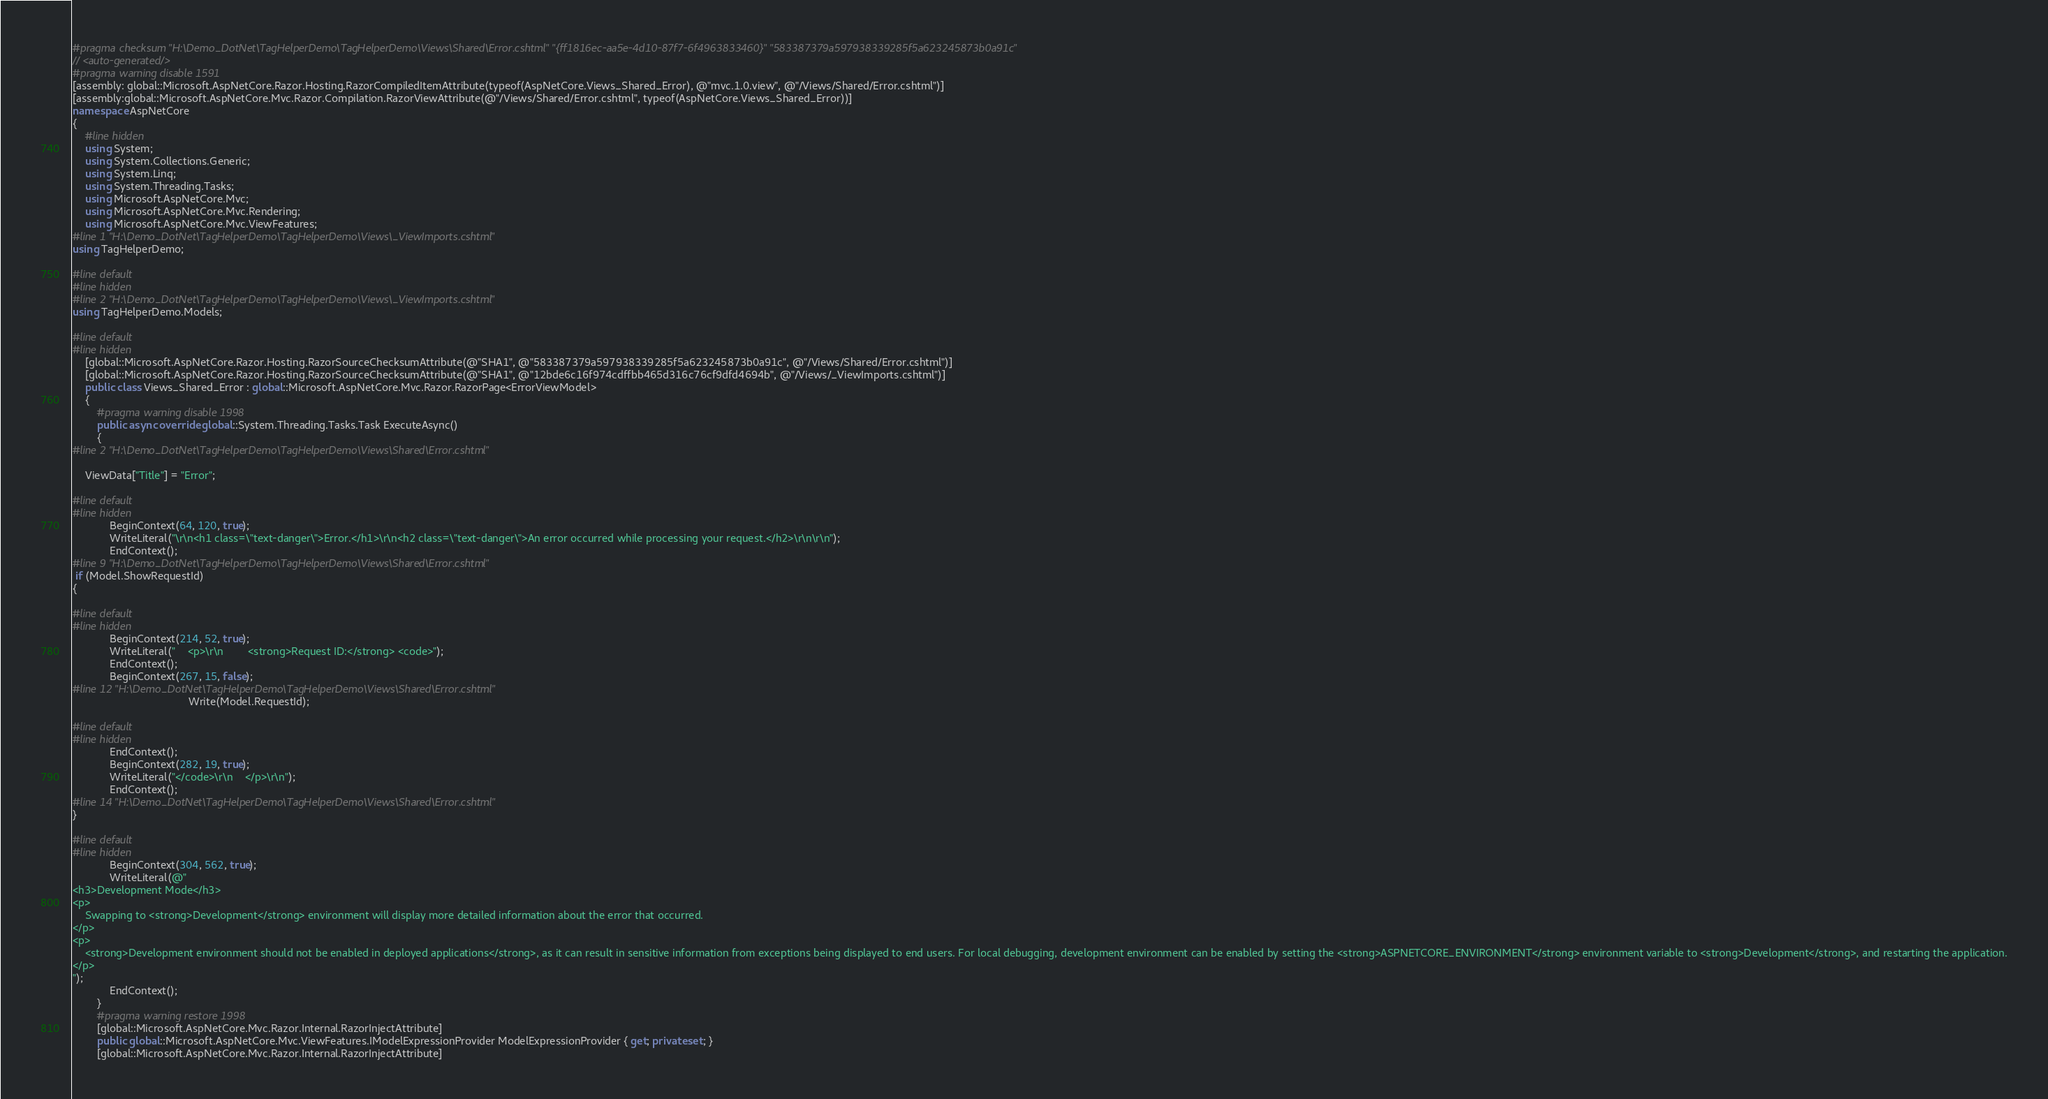Convert code to text. <code><loc_0><loc_0><loc_500><loc_500><_C#_>#pragma checksum "H:\Demo_DotNet\TagHelperDemo\TagHelperDemo\Views\Shared\Error.cshtml" "{ff1816ec-aa5e-4d10-87f7-6f4963833460}" "583387379a597938339285f5a623245873b0a91c"
// <auto-generated/>
#pragma warning disable 1591
[assembly: global::Microsoft.AspNetCore.Razor.Hosting.RazorCompiledItemAttribute(typeof(AspNetCore.Views_Shared_Error), @"mvc.1.0.view", @"/Views/Shared/Error.cshtml")]
[assembly:global::Microsoft.AspNetCore.Mvc.Razor.Compilation.RazorViewAttribute(@"/Views/Shared/Error.cshtml", typeof(AspNetCore.Views_Shared_Error))]
namespace AspNetCore
{
    #line hidden
    using System;
    using System.Collections.Generic;
    using System.Linq;
    using System.Threading.Tasks;
    using Microsoft.AspNetCore.Mvc;
    using Microsoft.AspNetCore.Mvc.Rendering;
    using Microsoft.AspNetCore.Mvc.ViewFeatures;
#line 1 "H:\Demo_DotNet\TagHelperDemo\TagHelperDemo\Views\_ViewImports.cshtml"
using TagHelperDemo;

#line default
#line hidden
#line 2 "H:\Demo_DotNet\TagHelperDemo\TagHelperDemo\Views\_ViewImports.cshtml"
using TagHelperDemo.Models;

#line default
#line hidden
    [global::Microsoft.AspNetCore.Razor.Hosting.RazorSourceChecksumAttribute(@"SHA1", @"583387379a597938339285f5a623245873b0a91c", @"/Views/Shared/Error.cshtml")]
    [global::Microsoft.AspNetCore.Razor.Hosting.RazorSourceChecksumAttribute(@"SHA1", @"12bde6c16f974cdffbb465d316c76cf9dfd4694b", @"/Views/_ViewImports.cshtml")]
    public class Views_Shared_Error : global::Microsoft.AspNetCore.Mvc.Razor.RazorPage<ErrorViewModel>
    {
        #pragma warning disable 1998
        public async override global::System.Threading.Tasks.Task ExecuteAsync()
        {
#line 2 "H:\Demo_DotNet\TagHelperDemo\TagHelperDemo\Views\Shared\Error.cshtml"
  
    ViewData["Title"] = "Error";

#line default
#line hidden
            BeginContext(64, 120, true);
            WriteLiteral("\r\n<h1 class=\"text-danger\">Error.</h1>\r\n<h2 class=\"text-danger\">An error occurred while processing your request.</h2>\r\n\r\n");
            EndContext();
#line 9 "H:\Demo_DotNet\TagHelperDemo\TagHelperDemo\Views\Shared\Error.cshtml"
 if (Model.ShowRequestId)
{

#line default
#line hidden
            BeginContext(214, 52, true);
            WriteLiteral("    <p>\r\n        <strong>Request ID:</strong> <code>");
            EndContext();
            BeginContext(267, 15, false);
#line 12 "H:\Demo_DotNet\TagHelperDemo\TagHelperDemo\Views\Shared\Error.cshtml"
                                      Write(Model.RequestId);

#line default
#line hidden
            EndContext();
            BeginContext(282, 19, true);
            WriteLiteral("</code>\r\n    </p>\r\n");
            EndContext();
#line 14 "H:\Demo_DotNet\TagHelperDemo\TagHelperDemo\Views\Shared\Error.cshtml"
}

#line default
#line hidden
            BeginContext(304, 562, true);
            WriteLiteral(@"
<h3>Development Mode</h3>
<p>
    Swapping to <strong>Development</strong> environment will display more detailed information about the error that occurred.
</p>
<p>
    <strong>Development environment should not be enabled in deployed applications</strong>, as it can result in sensitive information from exceptions being displayed to end users. For local debugging, development environment can be enabled by setting the <strong>ASPNETCORE_ENVIRONMENT</strong> environment variable to <strong>Development</strong>, and restarting the application.
</p>
");
            EndContext();
        }
        #pragma warning restore 1998
        [global::Microsoft.AspNetCore.Mvc.Razor.Internal.RazorInjectAttribute]
        public global::Microsoft.AspNetCore.Mvc.ViewFeatures.IModelExpressionProvider ModelExpressionProvider { get; private set; }
        [global::Microsoft.AspNetCore.Mvc.Razor.Internal.RazorInjectAttribute]</code> 